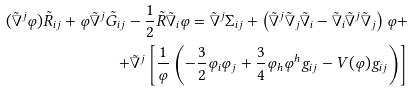<formula> <loc_0><loc_0><loc_500><loc_500>( \tilde { \nabla } ^ { j } \varphi ) \tilde { R } _ { i j } + \varphi \tilde { \nabla } ^ { j } \tilde { G } _ { i j } - \frac { 1 } { 2 } \tilde { R } \tilde { \nabla } _ { i } \varphi = \tilde { \nabla } ^ { j } \Sigma _ { i j } + \left ( \tilde { \nabla } ^ { j } \tilde { \nabla } _ { j } \tilde { \nabla } _ { i } - \tilde { \nabla } _ { i } \tilde { \nabla } ^ { j } \tilde { \nabla } _ { j } \right ) \varphi + \\ + \tilde { \nabla } ^ { j } \left [ \frac { 1 } { \varphi } \left ( - \frac { 3 } { 2 } \varphi _ { i } \varphi _ { j } + \frac { 3 } { 4 } \varphi _ { h } \varphi ^ { h } \/ g _ { i j } - V \/ ( \varphi ) g _ { i j } \right ) \right ]</formula> 